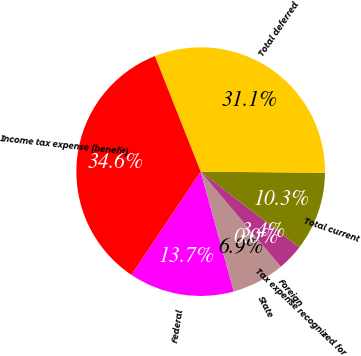Convert chart to OTSL. <chart><loc_0><loc_0><loc_500><loc_500><pie_chart><fcel>Federal<fcel>State<fcel>Foreign<fcel>Tax expense recognized for<fcel>Total current<fcel>Total deferred<fcel>Income tax expense (benefit)<nl><fcel>13.71%<fcel>6.86%<fcel>0.0%<fcel>3.43%<fcel>10.28%<fcel>31.15%<fcel>34.58%<nl></chart> 